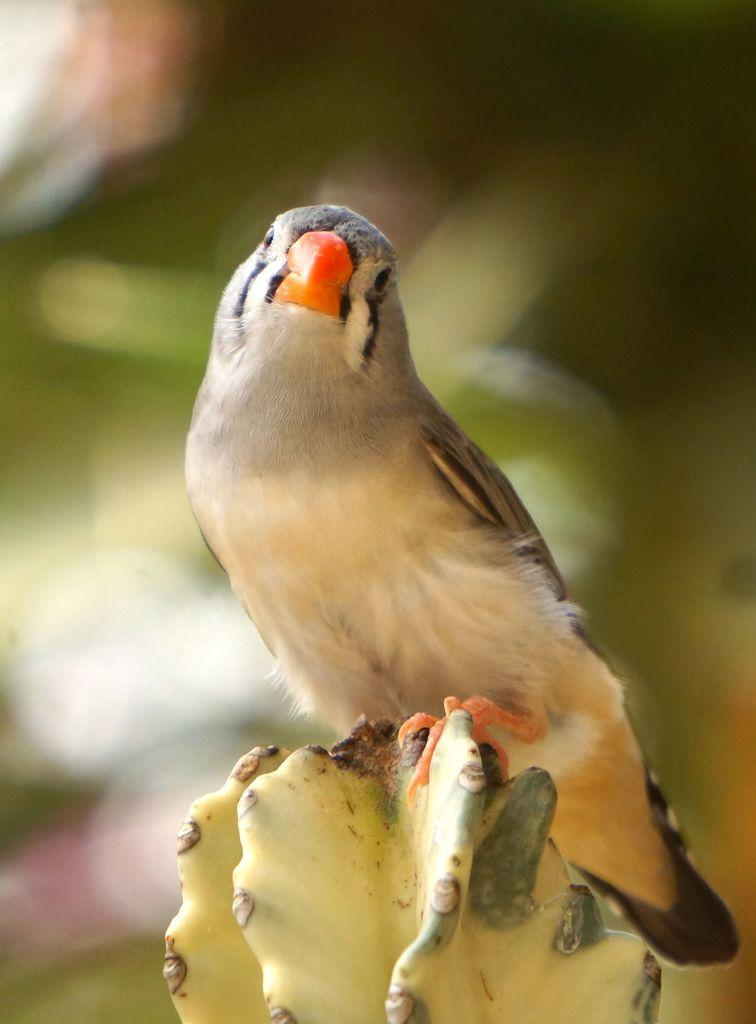What type of animal is in the image? There is a bird in the image. Where is the bird located? The bird is standing on a cactus plant. What color is the bird's beak? The bird has an orange-colored beak. Can you describe the background of the image? The background of the image is blurry. What type of creature is riding the train in the image? There is no train present in the image; it features a bird standing on a cactus plant. What type of sponge can be seen in the image? There is no sponge present in the image. 